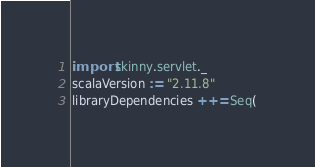Convert code to text. <code><loc_0><loc_0><loc_500><loc_500><_Scala_>import skinny.servlet._
scalaVersion := "2.11.8"
libraryDependencies ++= Seq(</code> 